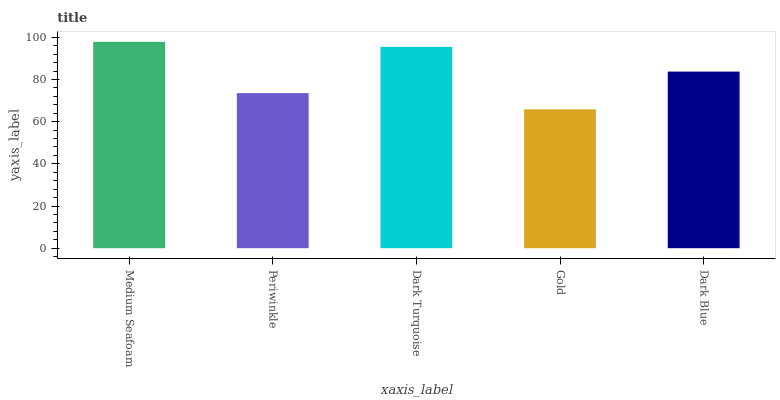Is Gold the minimum?
Answer yes or no. Yes. Is Medium Seafoam the maximum?
Answer yes or no. Yes. Is Periwinkle the minimum?
Answer yes or no. No. Is Periwinkle the maximum?
Answer yes or no. No. Is Medium Seafoam greater than Periwinkle?
Answer yes or no. Yes. Is Periwinkle less than Medium Seafoam?
Answer yes or no. Yes. Is Periwinkle greater than Medium Seafoam?
Answer yes or no. No. Is Medium Seafoam less than Periwinkle?
Answer yes or no. No. Is Dark Blue the high median?
Answer yes or no. Yes. Is Dark Blue the low median?
Answer yes or no. Yes. Is Periwinkle the high median?
Answer yes or no. No. Is Periwinkle the low median?
Answer yes or no. No. 